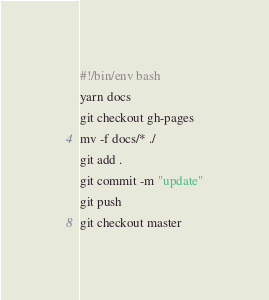Convert code to text. <code><loc_0><loc_0><loc_500><loc_500><_Bash_>#!/bin/env bash
yarn docs
git checkout gh-pages
mv -f docs/* ./
git add .
git commit -m "update"
git push
git checkout master</code> 